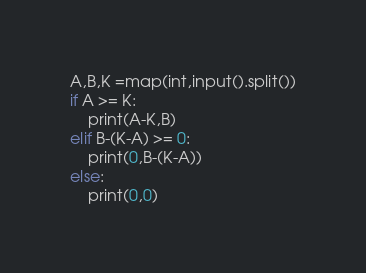Convert code to text. <code><loc_0><loc_0><loc_500><loc_500><_Python_>A,B,K =map(int,input().split())
if A >= K:
    print(A-K,B)
elif B-(K-A) >= 0:
    print(0,B-(K-A))
else:
    print(0,0)</code> 